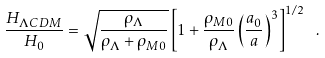<formula> <loc_0><loc_0><loc_500><loc_500>\frac { H _ { \Lambda C D M } } { H _ { 0 } } = \sqrt { \frac { \rho _ { \Lambda } } { \rho _ { \Lambda } + \rho _ { M 0 } } } \left [ 1 + \frac { \rho _ { M 0 } } { \rho _ { \Lambda } } \left ( \frac { a _ { 0 } } { a } \right ) ^ { 3 } \right ] ^ { 1 / 2 } \ .</formula> 